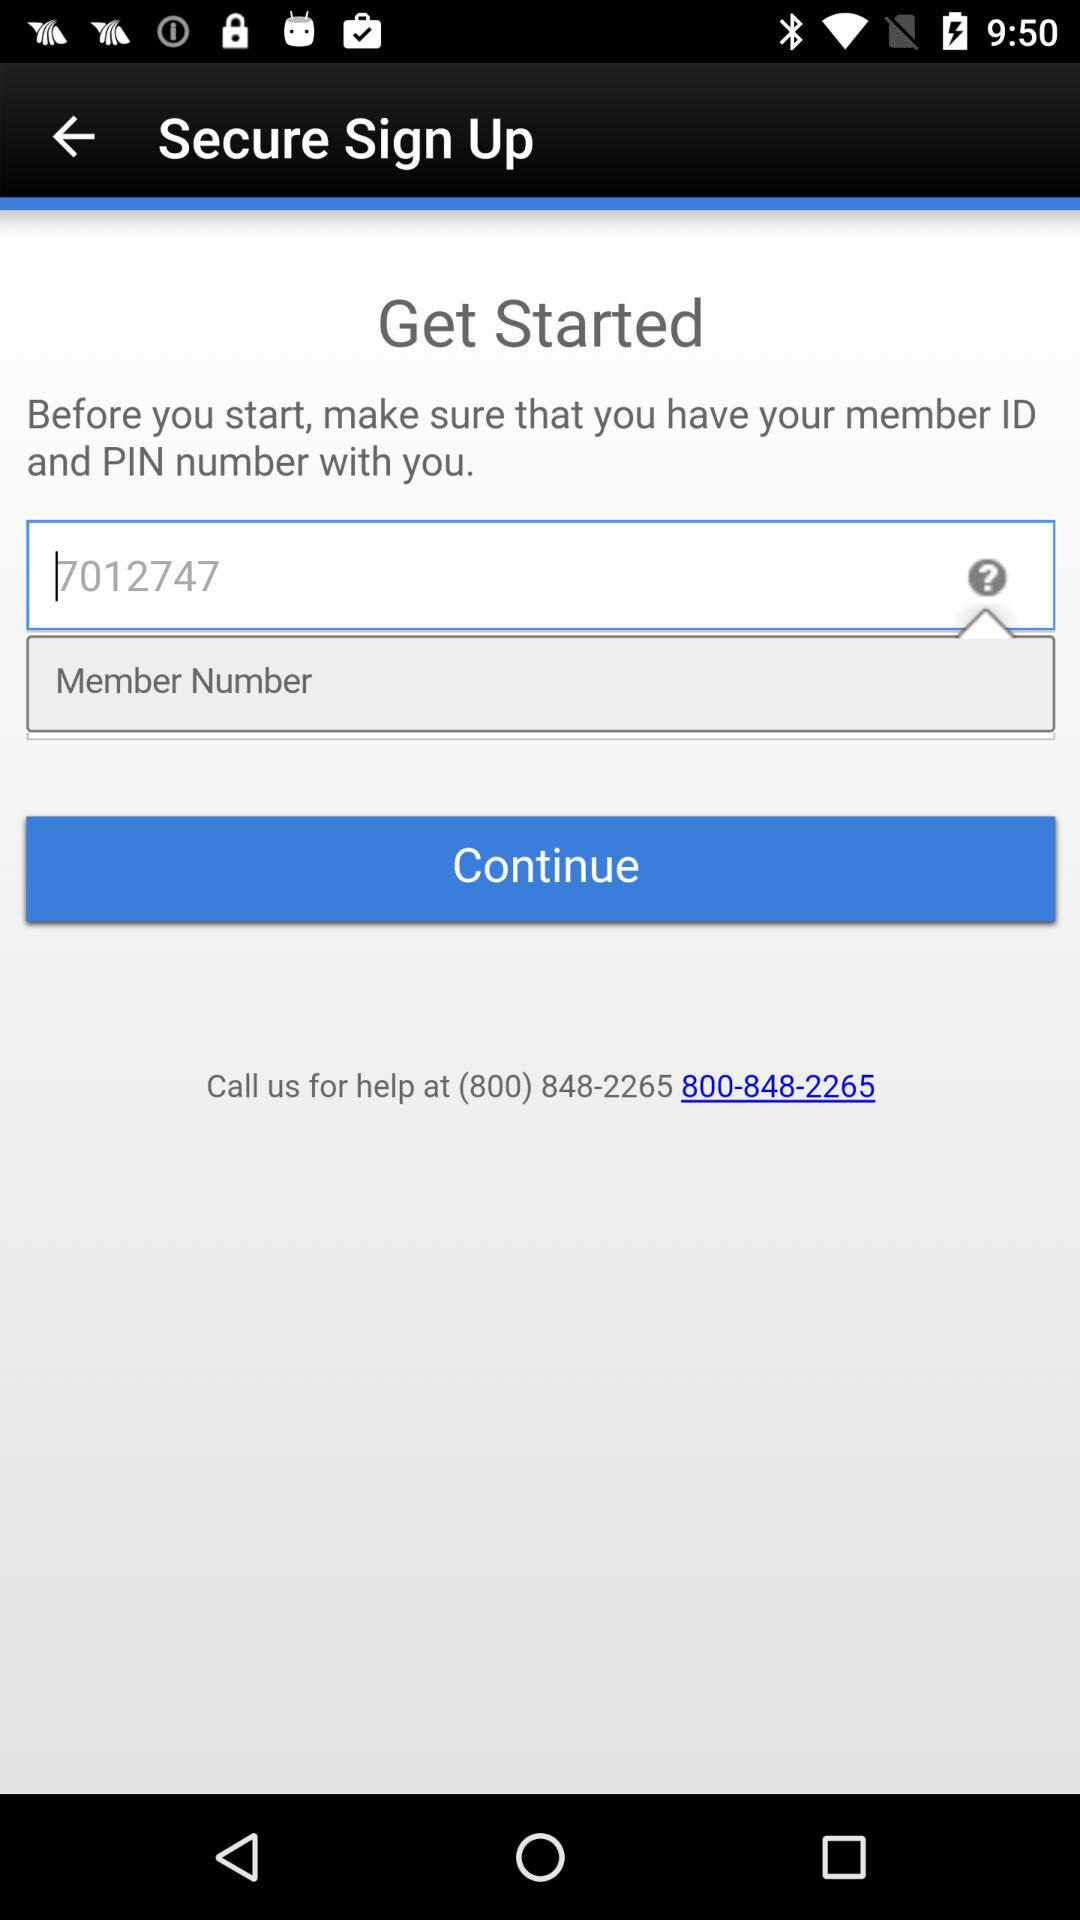What's the suggested member number? The suggested member number is 7012747. 